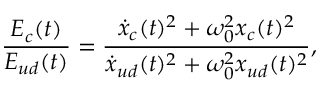Convert formula to latex. <formula><loc_0><loc_0><loc_500><loc_500>\frac { E _ { c } ( t ) } { E _ { u d } ( t ) } = \frac { \dot { x } _ { c } ( t ) ^ { 2 } + \omega _ { 0 } ^ { 2 } x _ { c } ( t ) ^ { 2 } } { \dot { x } _ { u d } ( t ) ^ { 2 } + \omega _ { 0 } ^ { 2 } x _ { u d } ( t ) ^ { 2 } } ,</formula> 